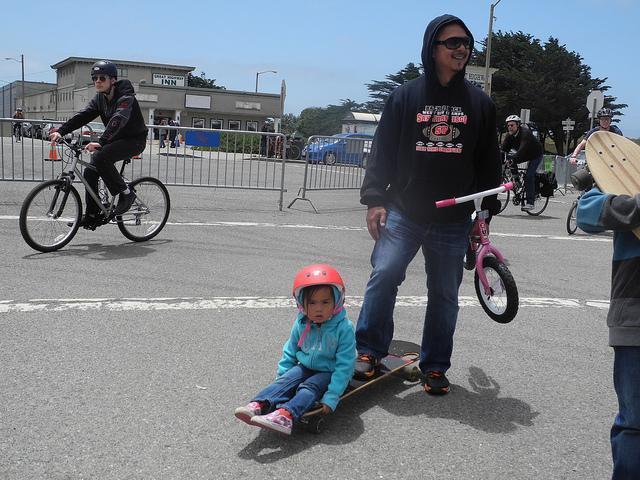Why is the child on the skateboard wearing a helmet?
Answer the question by selecting the correct answer among the 4 following choices.
Options: Protection, fashion, punishment, camouflage. Protection. 